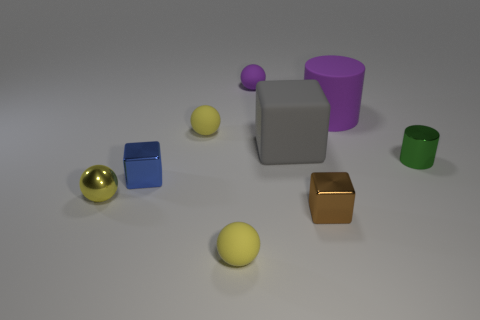The thing that is both on the right side of the large gray block and behind the tiny green metal cylinder has what shape?
Your answer should be compact. Cylinder. What is the color of the other tiny cube that is made of the same material as the blue cube?
Your answer should be compact. Brown. The yellow matte thing behind the small thing that is to the right of the purple matte object to the right of the tiny brown object is what shape?
Offer a terse response. Sphere. The yellow shiny ball is what size?
Your answer should be very brief. Small. There is a brown thing that is the same material as the blue thing; what shape is it?
Offer a very short reply. Cube. Is the number of yellow rubber objects that are to the right of the purple matte sphere less than the number of tiny yellow metal spheres?
Your answer should be very brief. Yes. What is the color of the small matte sphere in front of the big gray object?
Ensure brevity in your answer.  Yellow. Is there a large matte thing of the same shape as the tiny blue metal thing?
Offer a terse response. Yes. What number of other things are the same shape as the green metal thing?
Your answer should be compact. 1. Is the number of large rubber cylinders less than the number of small red spheres?
Offer a terse response. No. 